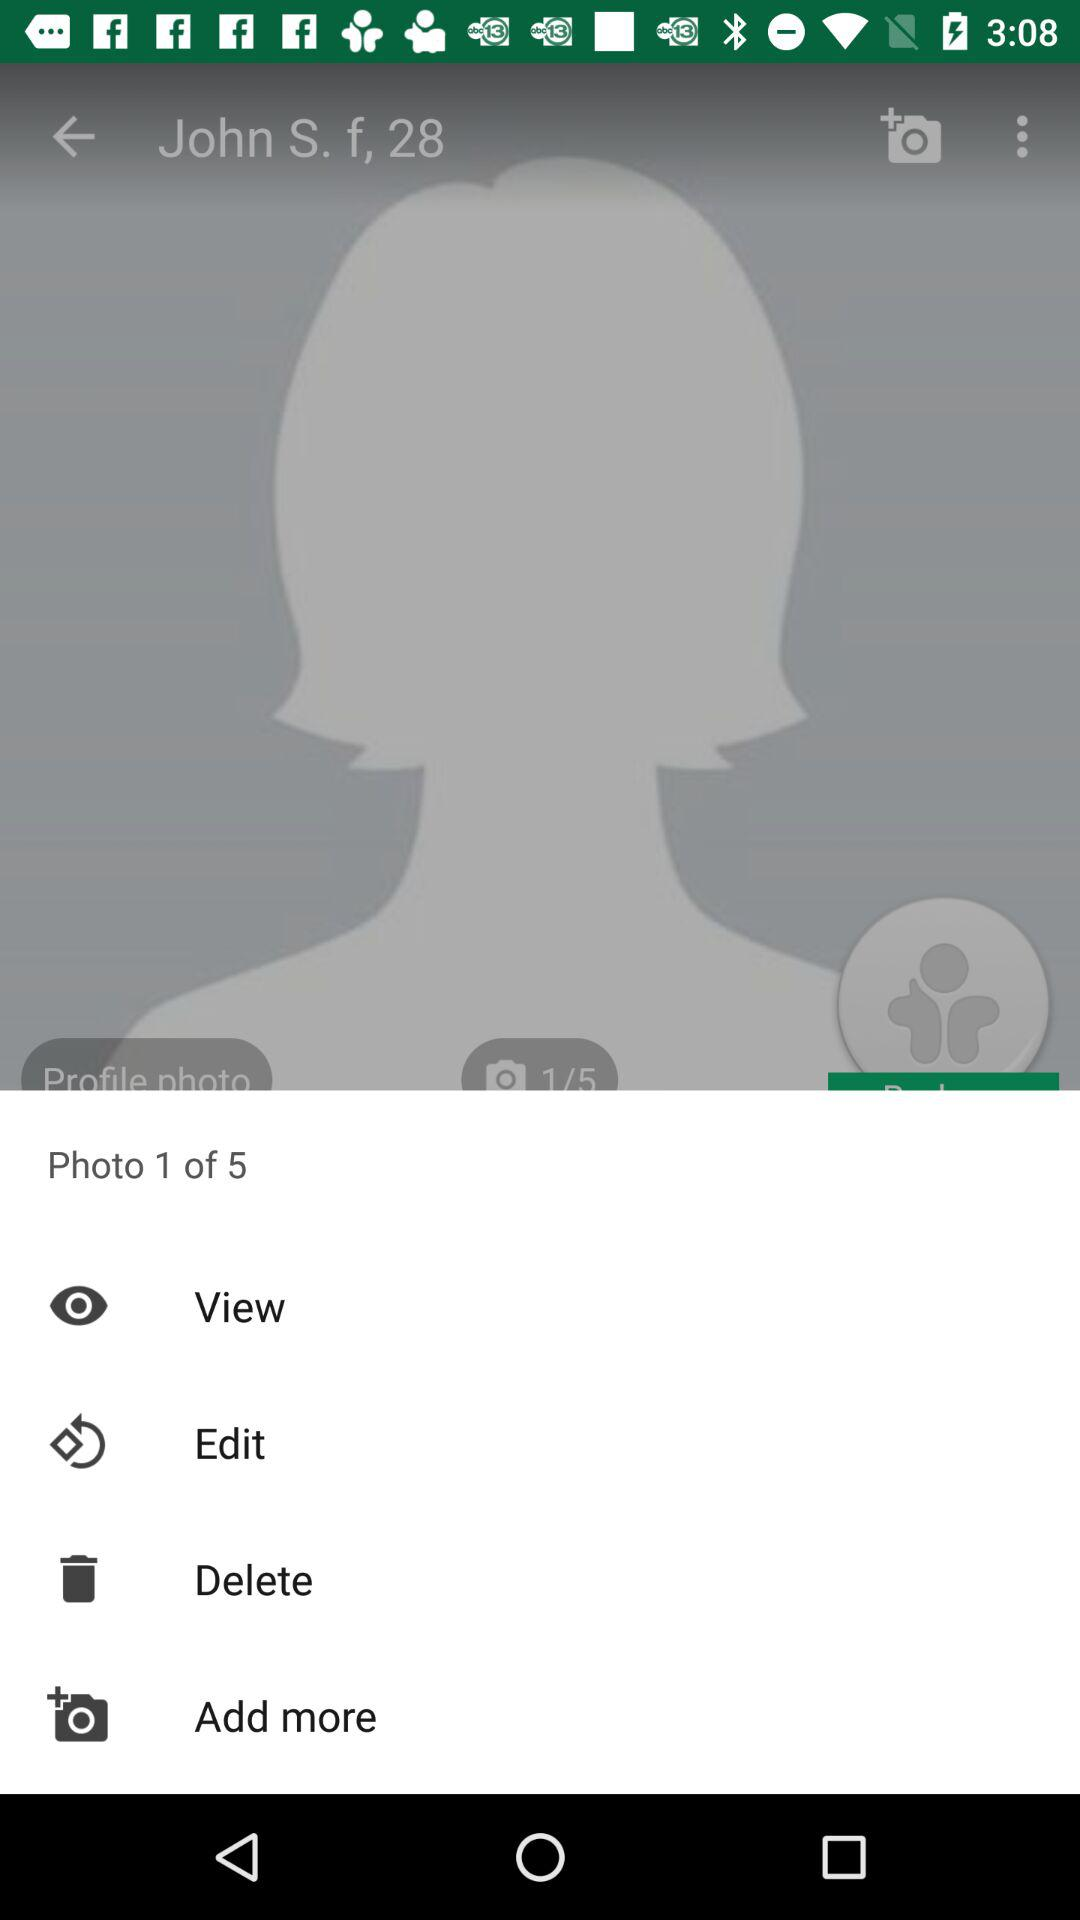What is the name of the user? The name of the user is "John S.". 